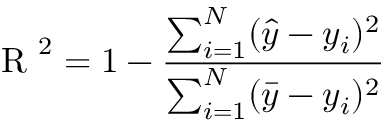<formula> <loc_0><loc_0><loc_500><loc_500>R ^ { 2 } = 1 - \frac { \sum _ { i = 1 } ^ { N } ( \hat { y } - y _ { i } ) ^ { 2 } } { \sum _ { i = 1 } ^ { N } ( \bar { y } - y _ { i } ) ^ { 2 } }</formula> 